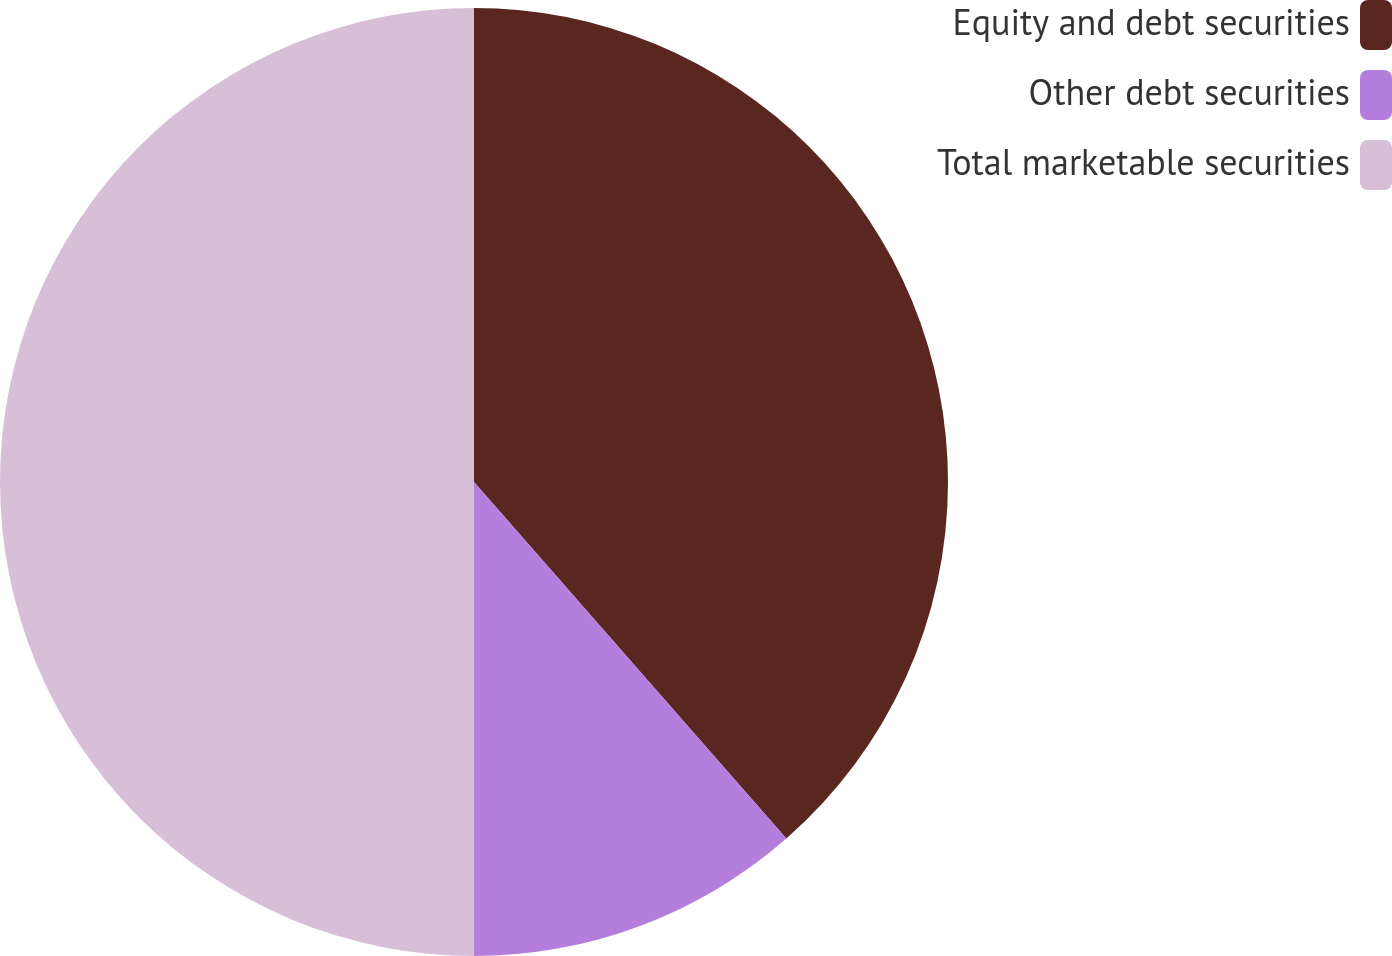Convert chart to OTSL. <chart><loc_0><loc_0><loc_500><loc_500><pie_chart><fcel>Equity and debt securities<fcel>Other debt securities<fcel>Total marketable securities<nl><fcel>38.55%<fcel>11.45%<fcel>50.0%<nl></chart> 